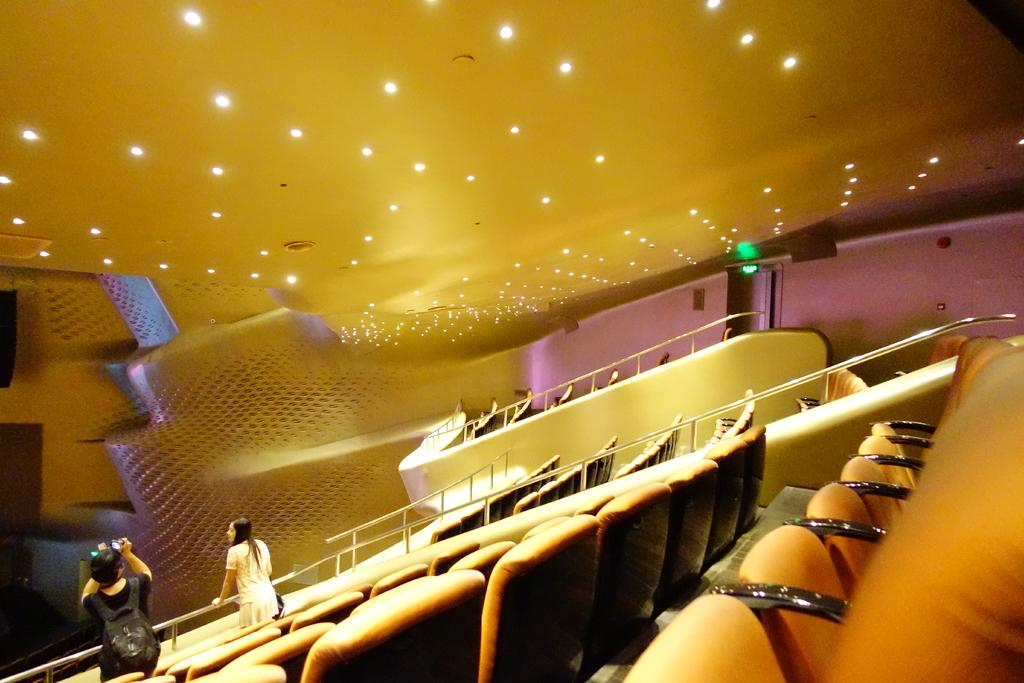What type of furniture is present in the image? There are chairs in the image. Can you describe the people in the image? Two people are standing at the bottom of the image. What is visible at the top of the image? There are ceiling lights visible at the top of the image. What type of jelly is being used to decorate the curtains in the image? There is no jelly or curtains present in the image. What is the weather like outside the room in the image? The provided facts do not mention any information about the weather or the room's location, so it cannot be determined from the image. 